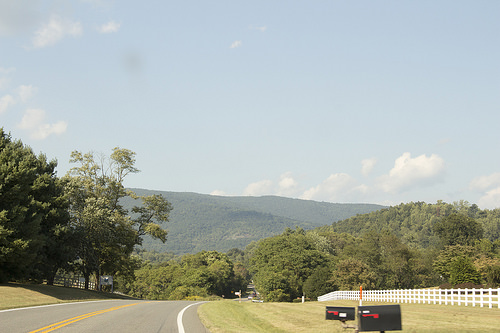<image>
Is there a fence in front of the mailbox? No. The fence is not in front of the mailbox. The spatial positioning shows a different relationship between these objects. 